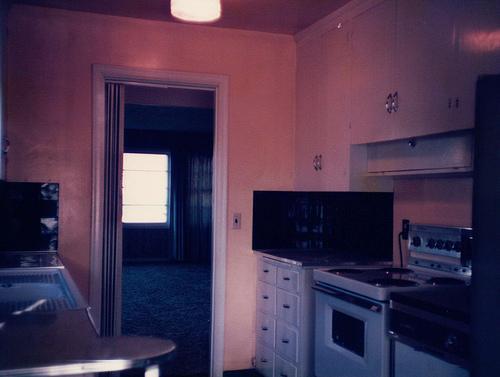How many people are in this picture?
Give a very brief answer. 0. 